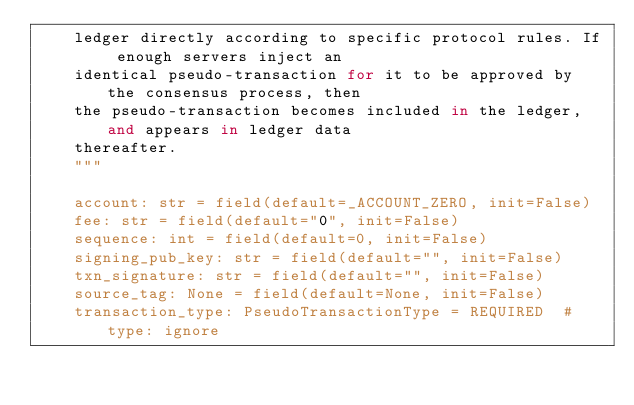<code> <loc_0><loc_0><loc_500><loc_500><_Python_>    ledger directly according to specific protocol rules. If enough servers inject an
    identical pseudo-transaction for it to be approved by the consensus process, then
    the pseudo-transaction becomes included in the ledger, and appears in ledger data
    thereafter.
    """

    account: str = field(default=_ACCOUNT_ZERO, init=False)
    fee: str = field(default="0", init=False)
    sequence: int = field(default=0, init=False)
    signing_pub_key: str = field(default="", init=False)
    txn_signature: str = field(default="", init=False)
    source_tag: None = field(default=None, init=False)
    transaction_type: PseudoTransactionType = REQUIRED  # type: ignore
</code> 